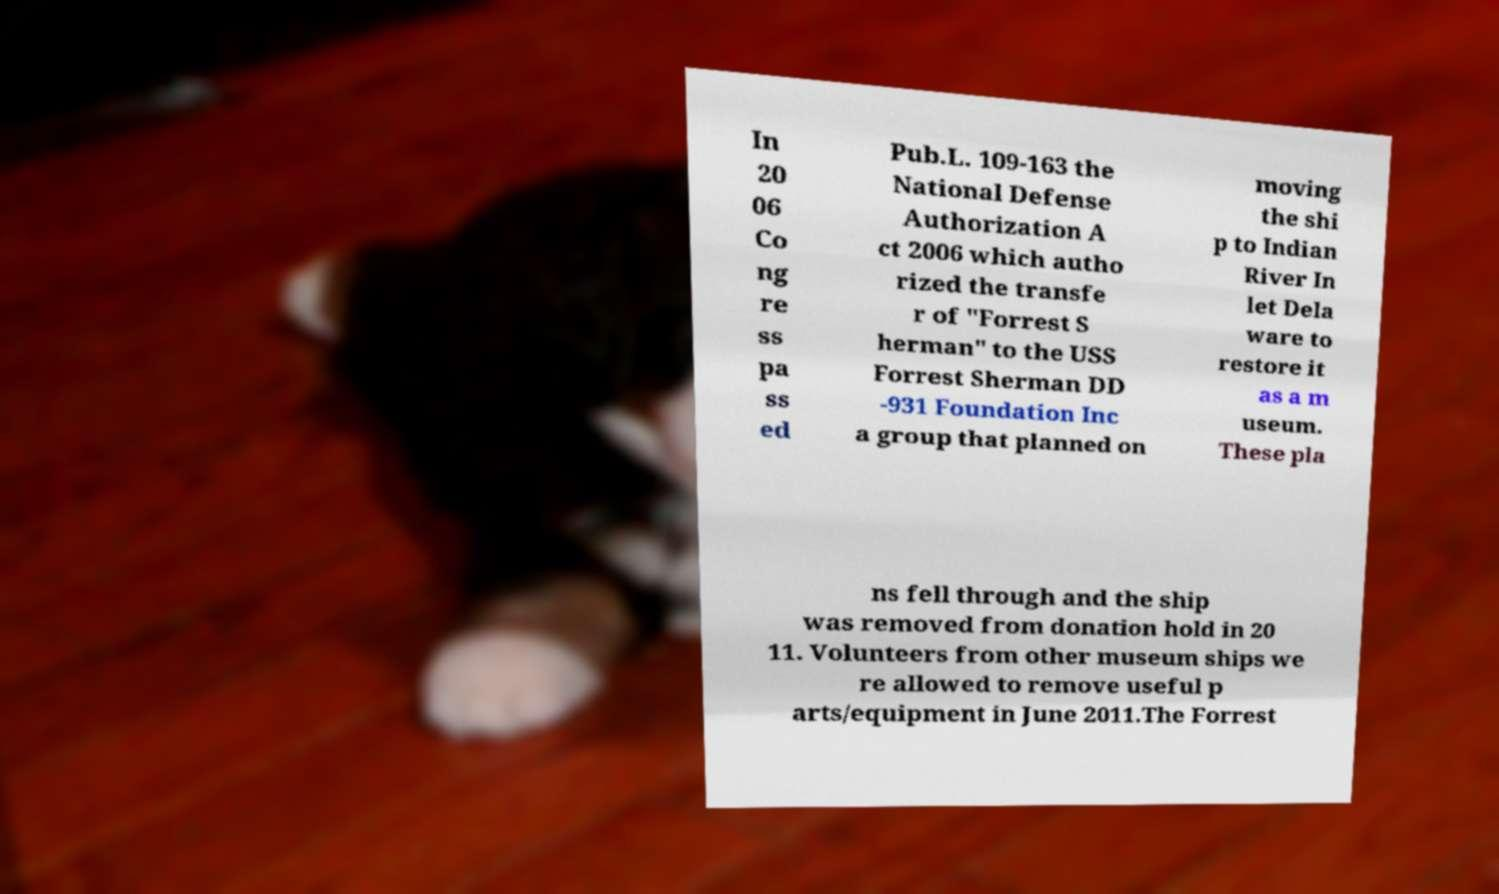Could you assist in decoding the text presented in this image and type it out clearly? In 20 06 Co ng re ss pa ss ed Pub.L. 109-163 the National Defense Authorization A ct 2006 which autho rized the transfe r of "Forrest S herman" to the USS Forrest Sherman DD -931 Foundation Inc a group that planned on moving the shi p to Indian River In let Dela ware to restore it as a m useum. These pla ns fell through and the ship was removed from donation hold in 20 11. Volunteers from other museum ships we re allowed to remove useful p arts/equipment in June 2011.The Forrest 